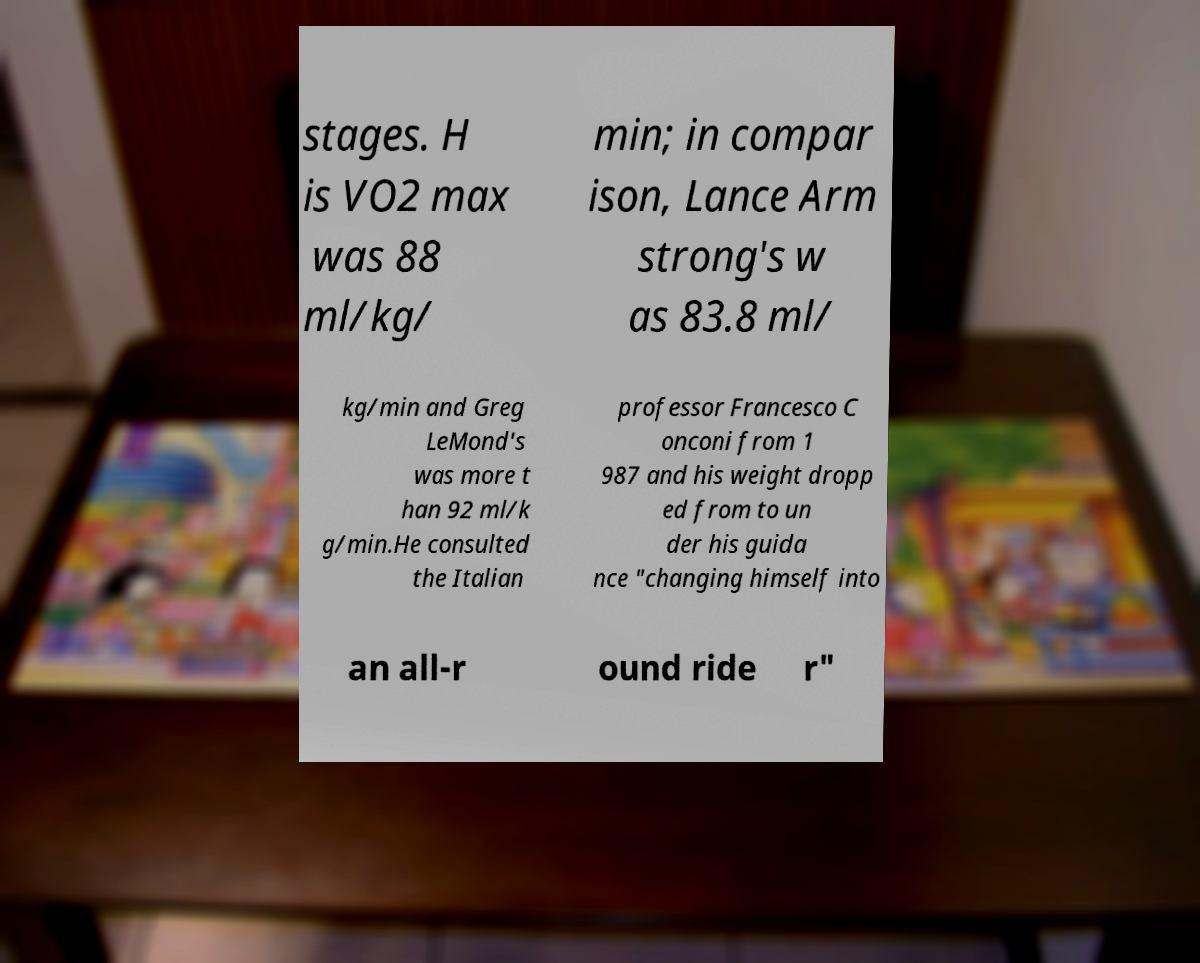I need the written content from this picture converted into text. Can you do that? stages. H is VO2 max was 88 ml/kg/ min; in compar ison, Lance Arm strong's w as 83.8 ml/ kg/min and Greg LeMond's was more t han 92 ml/k g/min.He consulted the Italian professor Francesco C onconi from 1 987 and his weight dropp ed from to un der his guida nce "changing himself into an all-r ound ride r" 